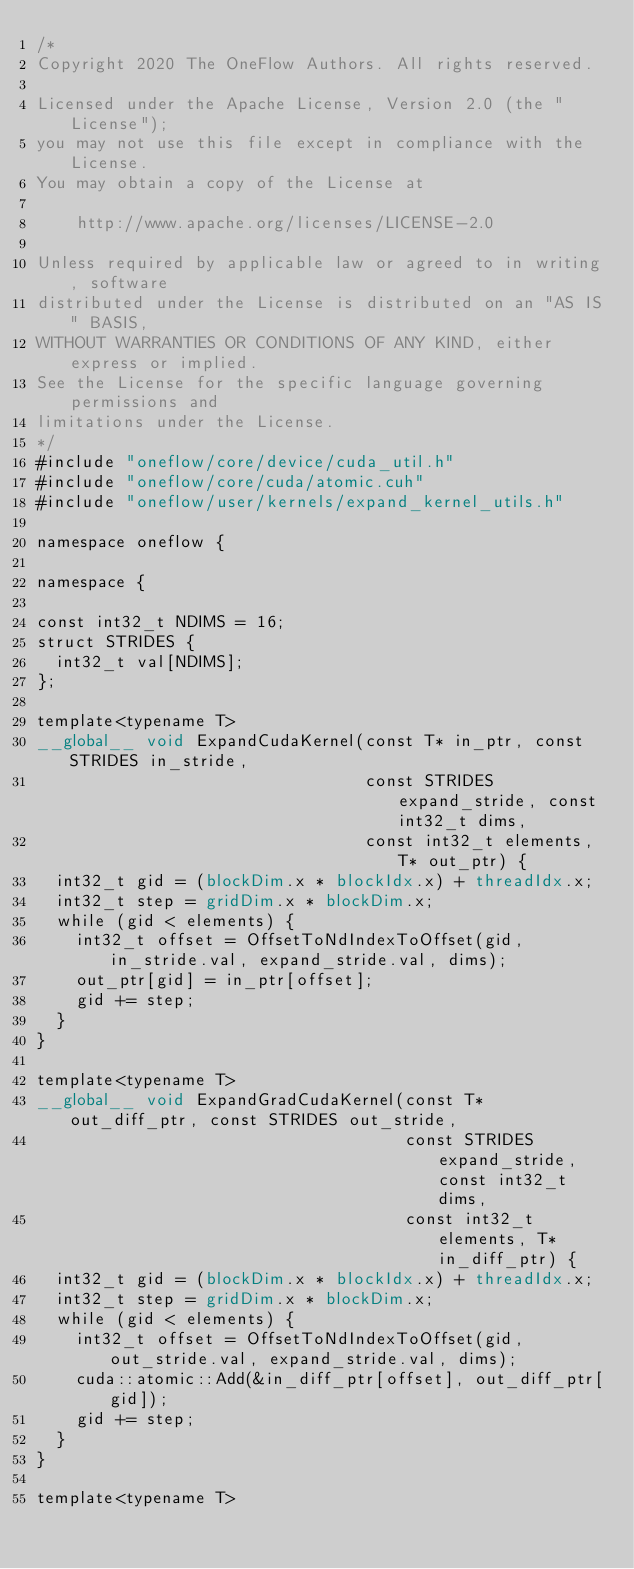<code> <loc_0><loc_0><loc_500><loc_500><_Cuda_>/*
Copyright 2020 The OneFlow Authors. All rights reserved.

Licensed under the Apache License, Version 2.0 (the "License");
you may not use this file except in compliance with the License.
You may obtain a copy of the License at

    http://www.apache.org/licenses/LICENSE-2.0

Unless required by applicable law or agreed to in writing, software
distributed under the License is distributed on an "AS IS" BASIS,
WITHOUT WARRANTIES OR CONDITIONS OF ANY KIND, either express or implied.
See the License for the specific language governing permissions and
limitations under the License.
*/
#include "oneflow/core/device/cuda_util.h"
#include "oneflow/core/cuda/atomic.cuh"
#include "oneflow/user/kernels/expand_kernel_utils.h"

namespace oneflow {

namespace {

const int32_t NDIMS = 16;
struct STRIDES {
  int32_t val[NDIMS];
};

template<typename T>
__global__ void ExpandCudaKernel(const T* in_ptr, const STRIDES in_stride,
                                 const STRIDES expand_stride, const int32_t dims,
                                 const int32_t elements, T* out_ptr) {
  int32_t gid = (blockDim.x * blockIdx.x) + threadIdx.x;
  int32_t step = gridDim.x * blockDim.x;
  while (gid < elements) {
    int32_t offset = OffsetToNdIndexToOffset(gid, in_stride.val, expand_stride.val, dims);
    out_ptr[gid] = in_ptr[offset];
    gid += step;
  }
}

template<typename T>
__global__ void ExpandGradCudaKernel(const T* out_diff_ptr, const STRIDES out_stride,
                                     const STRIDES expand_stride, const int32_t dims,
                                     const int32_t elements, T* in_diff_ptr) {
  int32_t gid = (blockDim.x * blockIdx.x) + threadIdx.x;
  int32_t step = gridDim.x * blockDim.x;
  while (gid < elements) {
    int32_t offset = OffsetToNdIndexToOffset(gid, out_stride.val, expand_stride.val, dims);
    cuda::atomic::Add(&in_diff_ptr[offset], out_diff_ptr[gid]);
    gid += step;
  }
}

template<typename T></code> 